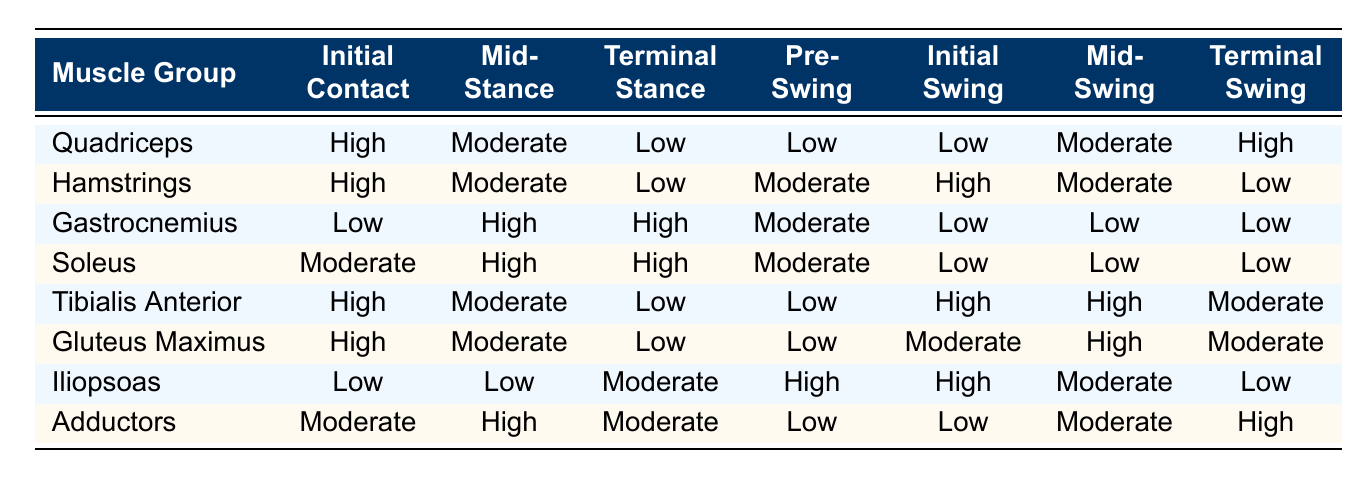What muscle group shows the highest activation during the Initial Contact phase? The table indicates that both the Quadriceps and Hamstrings have a "High" activation during the Initial Contact phase.
Answer: Quadriceps and Hamstrings During which phase do the Gastrocnemius and Soleus show the same level of activation? In the Mid-Stance and Terminal Stance phases, both the Gastrocnemius and Soleus have "High" activation levels.
Answer: Mid-Stance and Terminal Stance Is the activation level of the Tibialis Anterior consistent across all phases? The activation levels of the Tibialis Anterior vary across phases, showing "High," "Moderate," and "Low" activating levels, indicating inconsistency.
Answer: No Which muscle group has the lowest activation during the Terminal Swing phase? The table shows that the Hamstrings have "Low" activation during the Terminal Swing phase, which is the lowest compared to other muscle groups.
Answer: Hamstrings What is the activation level of the Gluteus Maximus during the Pre-Swing phase? According to the table, the Gluteus Maximus has "Low" activation during the Pre-Swing phase.
Answer: Low During which phase does the Iliopsoas have the highest activation? The Iliopsoas shows "High" activation during the Initial Swing and Pre-Swing phases, which are the highest when compared to others.
Answer: Initial Swing and Pre-Swing Which muscle group shows an increase in activation from Mid-Stance to Terminal Stance? The Soleus muscle group increases from "High" in Mid-Stance to "High" in Terminal Stance, which remains the same; however, the Gastrocnemius shows a similar increase reflecting high engagement in these phases.
Answer: Gastrocnemius and Soleus What is the difference in activation levels between Hamstrings and Quadriceps during the Pre-Swing phase? The Quadriceps have "Low" activation while the Hamstrings have "Moderate" activation during the Pre-Swing phase. Therefore, the difference is one level of activation.
Answer: One level difference 